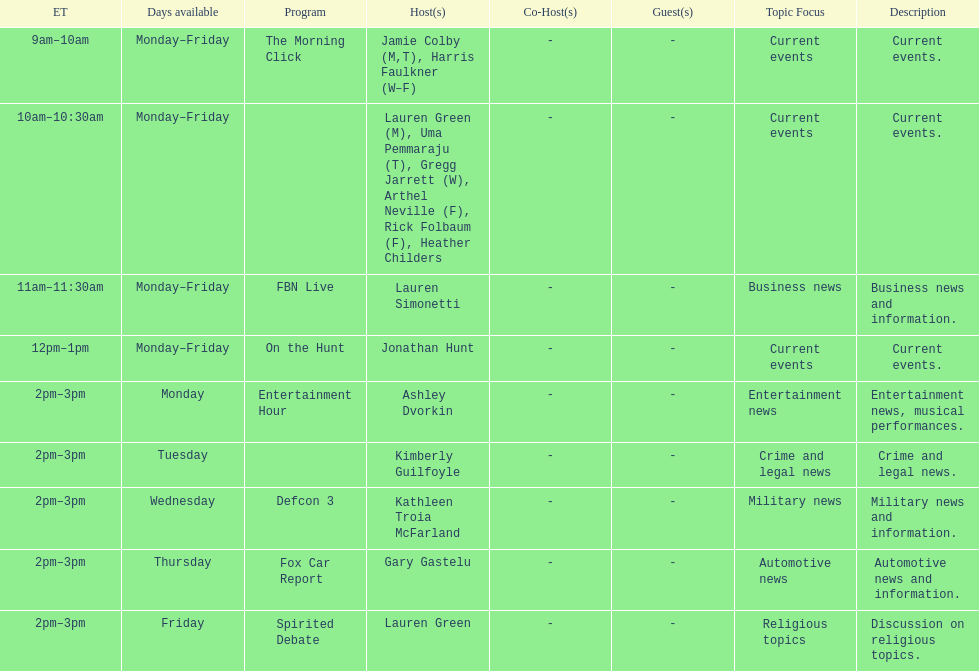Tell me the number of shows that only have one host per day. 7. 